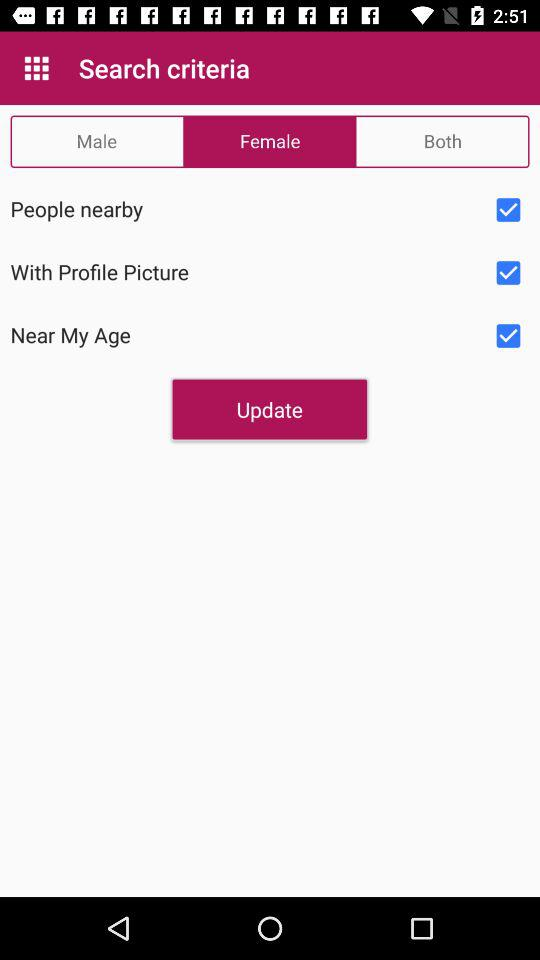What is the current status of "With Profile Picture"? The status is "on". 